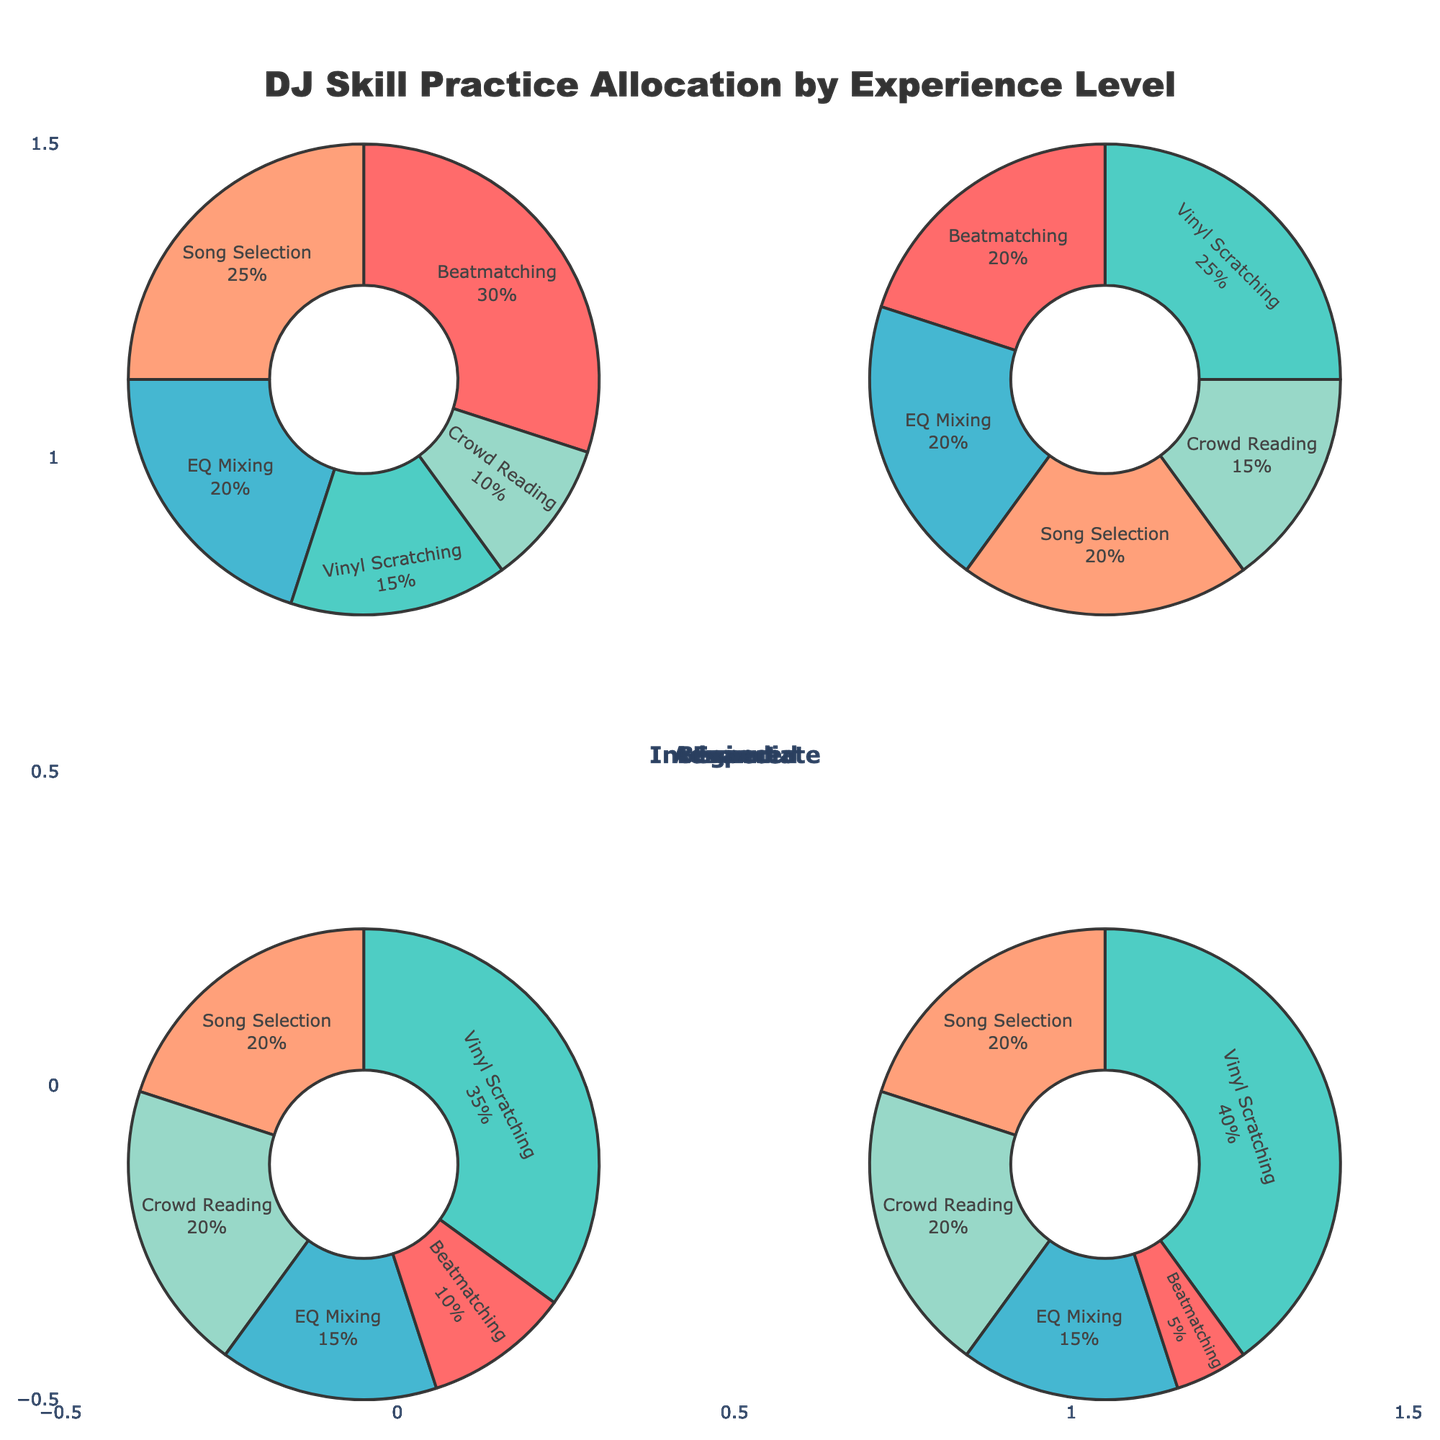Which skill occupies the largest portion of practice time for Beginners? Look at the Beginner's pie chart segment with the largest area. This is the skill with the largest percentage.
Answer: Beatmatching How much more percentage of practice time is allocated to Vinyl Scratching by Experts compared to Beginners? Find the percentage allocated to Vinyl Scratching for both Experts and Beginners and subtract the Beginner value from the Expert value (40% - 15%).
Answer: 25% Which experience level allocates the highest percentage to EQ Mixing? Compare the EQ Mixing segments across all experience levels and identify the one with the largest percentage.
Answer: Beginner What is the total percentage allocated to Song Selection across all experience levels? Sum the percentages allocated to Song Selection for Beginner, Intermediate, Advanced, and Expert (25% + 20% + 20% + 20%).
Answer: 85% Which skill consistently increases in allocated practice time as the experience level advances? Examine the segments across all experience levels and identify the skill that grows incrementally in percentage allocations.
Answer: Vinyl Scratching Compare the practice time allocation for Beatmatching between Intermediate and Advanced DJs. What's the difference? Find the Beatmatching percentage for both Intermediate and Advanced levels and calculate the difference (20% - 10%).
Answer: 10% For which experience level does Crowd Reading receive the smallest allocation, and what is the percentage? Look for the smallest segment labeled Crowd Reading across all experience levels.
Answer: Beginner, 10% How does the practice time allocation for Beatmatching change from Intermediate to Expert levels? Track the percentages for Beatmatching from Intermediate (20%), Advanced (10%), to Expert (5%) and describe the trend.
Answer: Decreases Which two skills share an equal percentage of practice time allocation for Experts? Identify the segments with equal percentages in the Expert level pie chart.
Answer: Song Selection and Crowd Reading What’s the average percentage allocated to Vinyl Scratching for all experience levels? Find the percentages for Vinyl Scratching at all levels (15%, 25%, 35%, 40%), sum them up, and divide by the number of levels (4).
Answer: 28.75% 